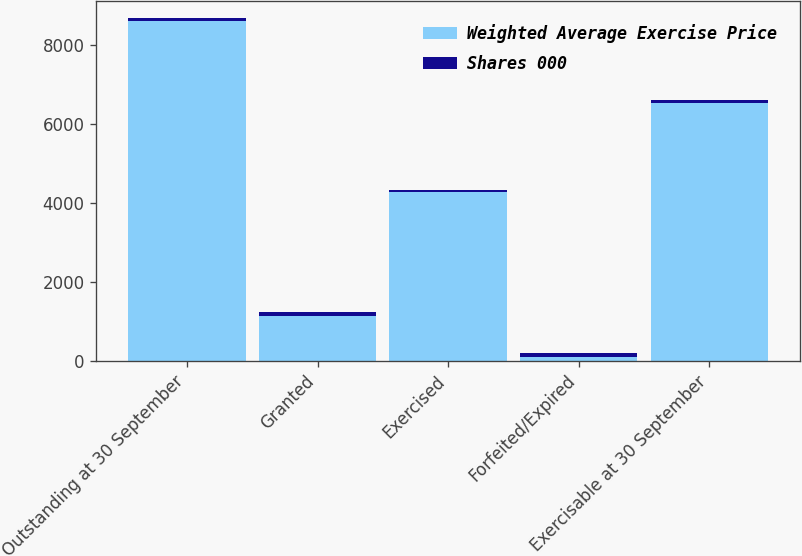Convert chart to OTSL. <chart><loc_0><loc_0><loc_500><loc_500><stacked_bar_chart><ecel><fcel>Outstanding at 30 September<fcel>Granted<fcel>Exercised<fcel>Forfeited/Expired<fcel>Exercisable at 30 September<nl><fcel>Weighted Average Exercise Price<fcel>8612<fcel>1140<fcel>4263<fcel>100<fcel>6531<nl><fcel>Shares 000<fcel>75.69<fcel>81.76<fcel>55.17<fcel>85.37<fcel>73.23<nl></chart> 